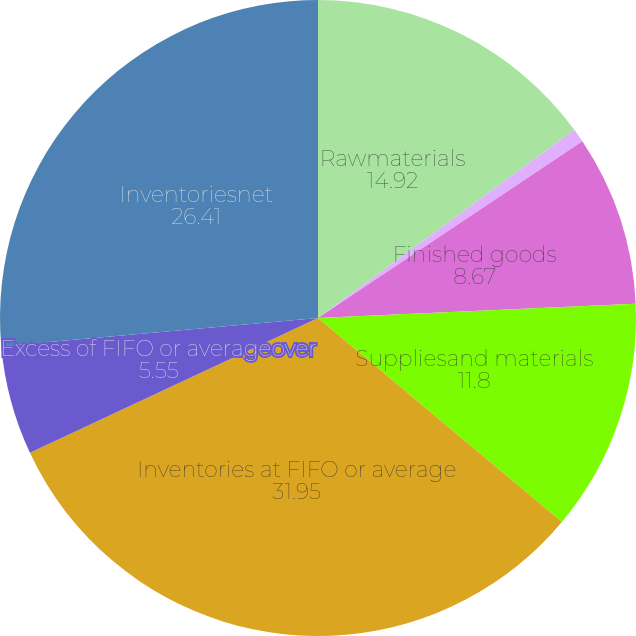Convert chart. <chart><loc_0><loc_0><loc_500><loc_500><pie_chart><fcel>Rawmaterials<fcel>Work in process<fcel>Finished goods<fcel>Suppliesand materials<fcel>Inventories at FIFO or average<fcel>Excess of FIFO or averageover<fcel>Inventoriesnet<nl><fcel>14.92%<fcel>0.7%<fcel>8.67%<fcel>11.8%<fcel>31.95%<fcel>5.55%<fcel>26.41%<nl></chart> 